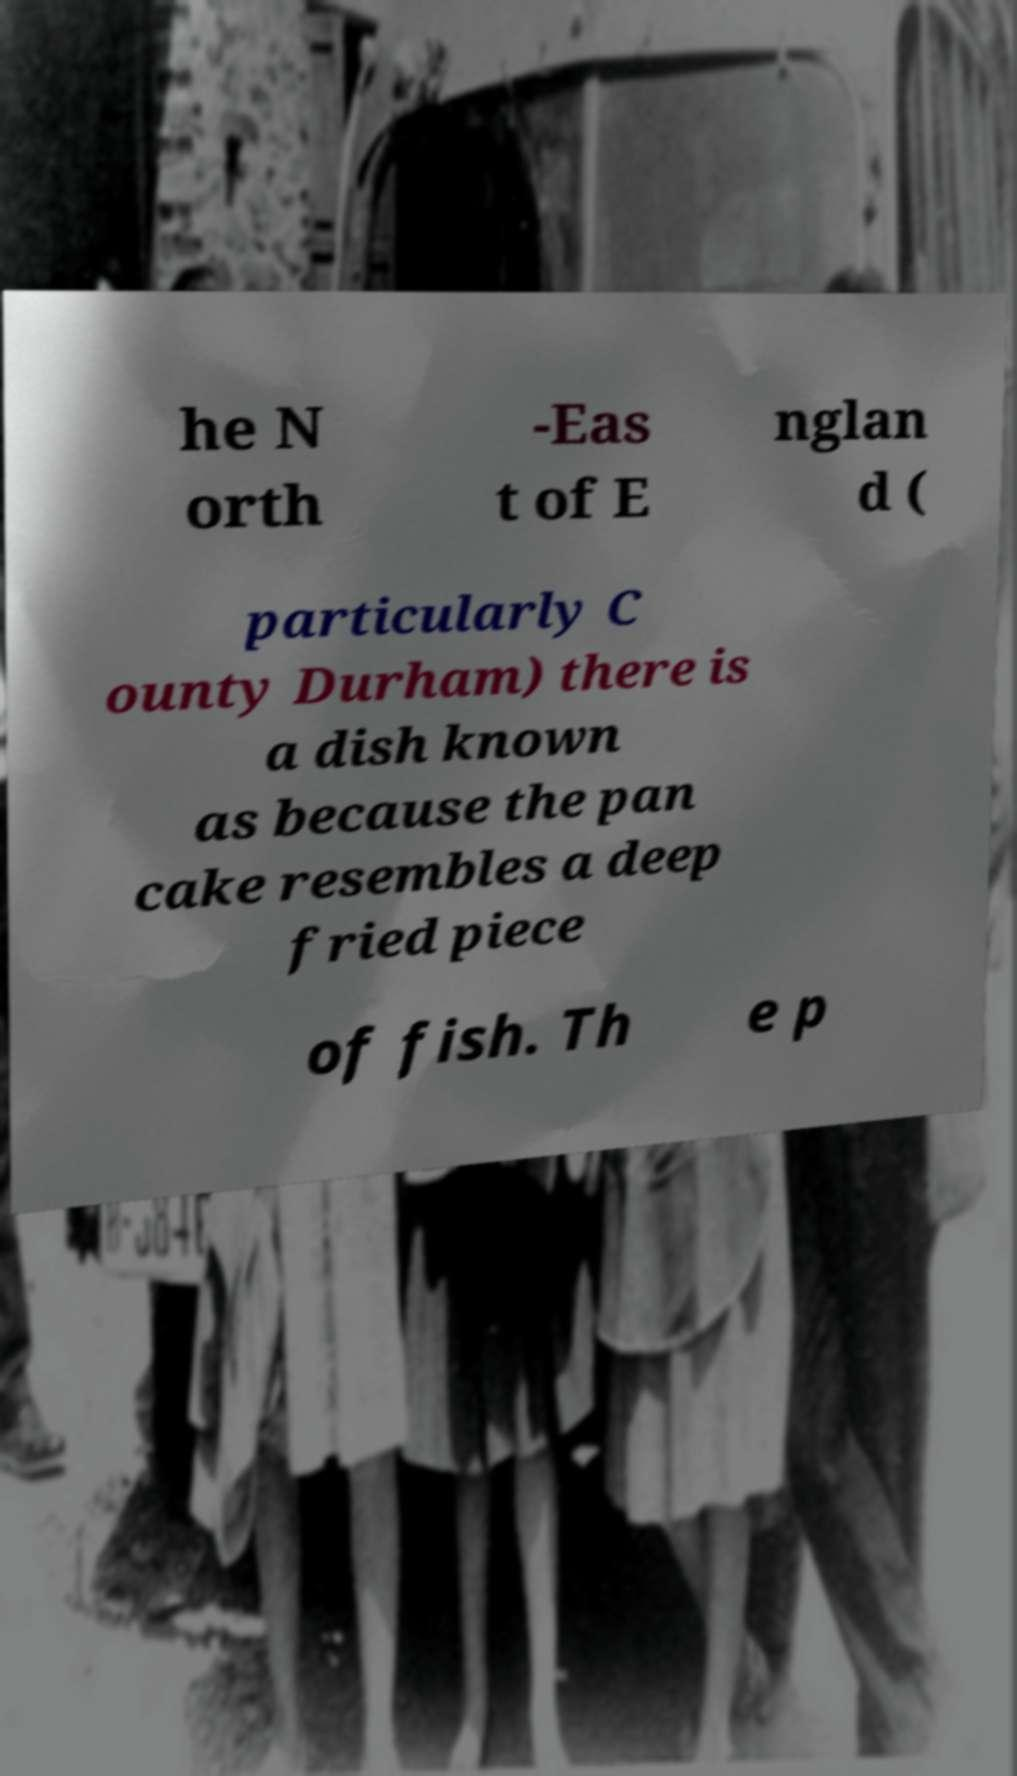Can you accurately transcribe the text from the provided image for me? he N orth -Eas t of E nglan d ( particularly C ounty Durham) there is a dish known as because the pan cake resembles a deep fried piece of fish. Th e p 